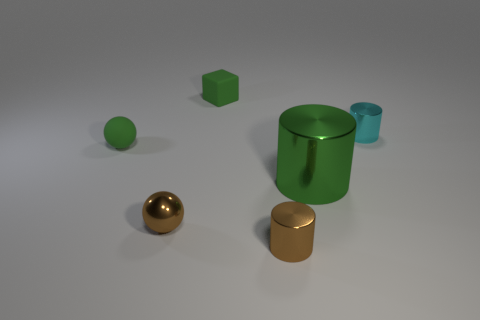There is a tiny cylinder in front of the thing that is to the right of the large shiny cylinder; are there any tiny green matte spheres that are behind it?
Your answer should be very brief. Yes. There is a big green object; are there any small cylinders on the right side of it?
Your answer should be very brief. Yes. There is a shiny cylinder that is on the left side of the green metal object; how many large metallic cylinders are behind it?
Ensure brevity in your answer.  1. There is a brown cylinder; does it have the same size as the green thing in front of the green sphere?
Ensure brevity in your answer.  No. Is there a tiny matte sphere of the same color as the small matte cube?
Your answer should be compact. Yes. There is a green cylinder that is the same material as the small cyan object; what is its size?
Provide a short and direct response. Large. Are the green cube and the small green ball made of the same material?
Offer a terse response. Yes. The cylinder in front of the green object on the right side of the small brown shiny thing that is to the right of the green rubber block is what color?
Give a very brief answer. Brown. There is a cyan thing; what shape is it?
Provide a short and direct response. Cylinder. There is a tiny cube; does it have the same color as the small ball behind the big metallic cylinder?
Your answer should be very brief. Yes. 